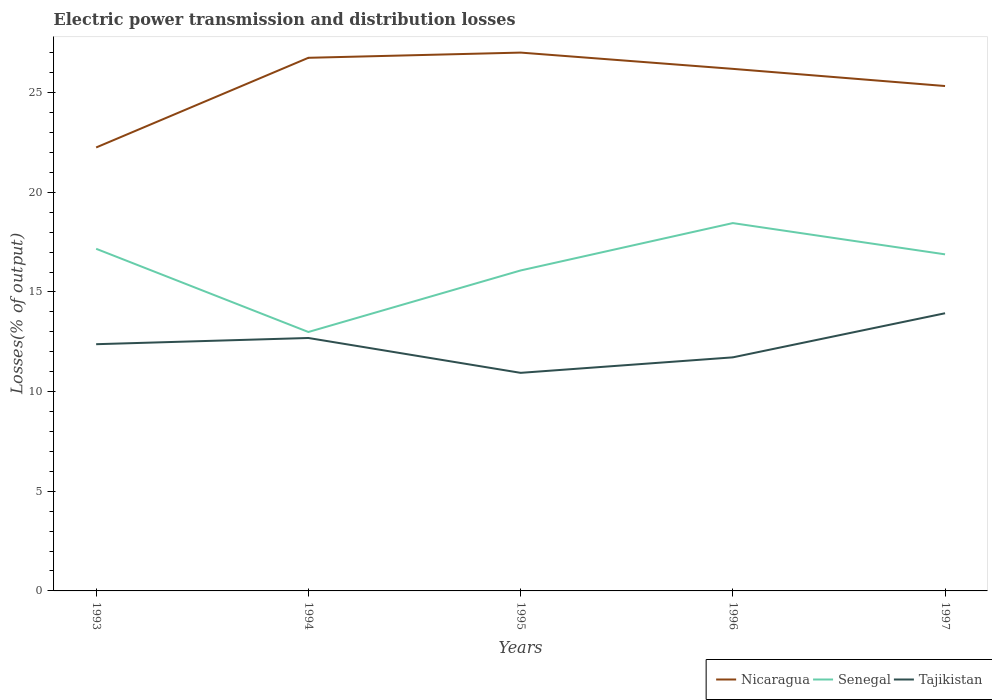Is the number of lines equal to the number of legend labels?
Your answer should be compact. Yes. Across all years, what is the maximum electric power transmission and distribution losses in Tajikistan?
Offer a terse response. 10.94. What is the total electric power transmission and distribution losses in Tajikistan in the graph?
Provide a succinct answer. -0.78. What is the difference between the highest and the second highest electric power transmission and distribution losses in Nicaragua?
Your response must be concise. 4.76. How many years are there in the graph?
Provide a short and direct response. 5. Are the values on the major ticks of Y-axis written in scientific E-notation?
Your answer should be compact. No. Does the graph contain any zero values?
Ensure brevity in your answer.  No. Where does the legend appear in the graph?
Offer a terse response. Bottom right. What is the title of the graph?
Provide a succinct answer. Electric power transmission and distribution losses. Does "Singapore" appear as one of the legend labels in the graph?
Offer a very short reply. No. What is the label or title of the X-axis?
Offer a very short reply. Years. What is the label or title of the Y-axis?
Provide a succinct answer. Losses(% of output). What is the Losses(% of output) of Nicaragua in 1993?
Provide a succinct answer. 22.25. What is the Losses(% of output) of Senegal in 1993?
Provide a succinct answer. 17.16. What is the Losses(% of output) of Tajikistan in 1993?
Your response must be concise. 12.38. What is the Losses(% of output) of Nicaragua in 1994?
Your answer should be very brief. 26.75. What is the Losses(% of output) of Senegal in 1994?
Provide a succinct answer. 12.99. What is the Losses(% of output) in Tajikistan in 1994?
Offer a terse response. 12.69. What is the Losses(% of output) of Nicaragua in 1995?
Ensure brevity in your answer.  27.01. What is the Losses(% of output) in Senegal in 1995?
Make the answer very short. 16.08. What is the Losses(% of output) in Tajikistan in 1995?
Give a very brief answer. 10.94. What is the Losses(% of output) of Nicaragua in 1996?
Your answer should be compact. 26.19. What is the Losses(% of output) in Senegal in 1996?
Ensure brevity in your answer.  18.45. What is the Losses(% of output) of Tajikistan in 1996?
Make the answer very short. 11.72. What is the Losses(% of output) of Nicaragua in 1997?
Ensure brevity in your answer.  25.33. What is the Losses(% of output) in Senegal in 1997?
Provide a succinct answer. 16.89. What is the Losses(% of output) in Tajikistan in 1997?
Keep it short and to the point. 13.93. Across all years, what is the maximum Losses(% of output) of Nicaragua?
Offer a very short reply. 27.01. Across all years, what is the maximum Losses(% of output) of Senegal?
Your response must be concise. 18.45. Across all years, what is the maximum Losses(% of output) in Tajikistan?
Your answer should be compact. 13.93. Across all years, what is the minimum Losses(% of output) in Nicaragua?
Provide a succinct answer. 22.25. Across all years, what is the minimum Losses(% of output) in Senegal?
Keep it short and to the point. 12.99. Across all years, what is the minimum Losses(% of output) in Tajikistan?
Offer a very short reply. 10.94. What is the total Losses(% of output) of Nicaragua in the graph?
Offer a very short reply. 127.52. What is the total Losses(% of output) of Senegal in the graph?
Your response must be concise. 81.57. What is the total Losses(% of output) in Tajikistan in the graph?
Your response must be concise. 61.66. What is the difference between the Losses(% of output) of Nicaragua in 1993 and that in 1994?
Keep it short and to the point. -4.5. What is the difference between the Losses(% of output) in Senegal in 1993 and that in 1994?
Your answer should be compact. 4.17. What is the difference between the Losses(% of output) of Tajikistan in 1993 and that in 1994?
Your response must be concise. -0.31. What is the difference between the Losses(% of output) of Nicaragua in 1993 and that in 1995?
Make the answer very short. -4.76. What is the difference between the Losses(% of output) of Senegal in 1993 and that in 1995?
Your answer should be compact. 1.09. What is the difference between the Losses(% of output) of Tajikistan in 1993 and that in 1995?
Make the answer very short. 1.44. What is the difference between the Losses(% of output) in Nicaragua in 1993 and that in 1996?
Ensure brevity in your answer.  -3.94. What is the difference between the Losses(% of output) of Senegal in 1993 and that in 1996?
Your response must be concise. -1.29. What is the difference between the Losses(% of output) of Tajikistan in 1993 and that in 1996?
Keep it short and to the point. 0.66. What is the difference between the Losses(% of output) of Nicaragua in 1993 and that in 1997?
Your answer should be compact. -3.08. What is the difference between the Losses(% of output) in Senegal in 1993 and that in 1997?
Ensure brevity in your answer.  0.28. What is the difference between the Losses(% of output) in Tajikistan in 1993 and that in 1997?
Offer a terse response. -1.55. What is the difference between the Losses(% of output) of Nicaragua in 1994 and that in 1995?
Your response must be concise. -0.26. What is the difference between the Losses(% of output) of Senegal in 1994 and that in 1995?
Make the answer very short. -3.09. What is the difference between the Losses(% of output) in Tajikistan in 1994 and that in 1995?
Offer a terse response. 1.75. What is the difference between the Losses(% of output) of Nicaragua in 1994 and that in 1996?
Offer a terse response. 0.56. What is the difference between the Losses(% of output) in Senegal in 1994 and that in 1996?
Your answer should be very brief. -5.46. What is the difference between the Losses(% of output) of Tajikistan in 1994 and that in 1996?
Ensure brevity in your answer.  0.97. What is the difference between the Losses(% of output) in Nicaragua in 1994 and that in 1997?
Your response must be concise. 1.42. What is the difference between the Losses(% of output) in Senegal in 1994 and that in 1997?
Your answer should be compact. -3.9. What is the difference between the Losses(% of output) in Tajikistan in 1994 and that in 1997?
Ensure brevity in your answer.  -1.24. What is the difference between the Losses(% of output) of Nicaragua in 1995 and that in 1996?
Your answer should be compact. 0.82. What is the difference between the Losses(% of output) of Senegal in 1995 and that in 1996?
Provide a succinct answer. -2.38. What is the difference between the Losses(% of output) of Tajikistan in 1995 and that in 1996?
Your answer should be compact. -0.78. What is the difference between the Losses(% of output) of Nicaragua in 1995 and that in 1997?
Provide a succinct answer. 1.68. What is the difference between the Losses(% of output) in Senegal in 1995 and that in 1997?
Give a very brief answer. -0.81. What is the difference between the Losses(% of output) of Tajikistan in 1995 and that in 1997?
Provide a succinct answer. -2.99. What is the difference between the Losses(% of output) in Nicaragua in 1996 and that in 1997?
Your answer should be very brief. 0.86. What is the difference between the Losses(% of output) in Senegal in 1996 and that in 1997?
Your answer should be compact. 1.57. What is the difference between the Losses(% of output) of Tajikistan in 1996 and that in 1997?
Ensure brevity in your answer.  -2.21. What is the difference between the Losses(% of output) of Nicaragua in 1993 and the Losses(% of output) of Senegal in 1994?
Offer a very short reply. 9.26. What is the difference between the Losses(% of output) in Nicaragua in 1993 and the Losses(% of output) in Tajikistan in 1994?
Keep it short and to the point. 9.56. What is the difference between the Losses(% of output) in Senegal in 1993 and the Losses(% of output) in Tajikistan in 1994?
Provide a succinct answer. 4.47. What is the difference between the Losses(% of output) in Nicaragua in 1993 and the Losses(% of output) in Senegal in 1995?
Keep it short and to the point. 6.17. What is the difference between the Losses(% of output) in Nicaragua in 1993 and the Losses(% of output) in Tajikistan in 1995?
Keep it short and to the point. 11.31. What is the difference between the Losses(% of output) in Senegal in 1993 and the Losses(% of output) in Tajikistan in 1995?
Your answer should be compact. 6.22. What is the difference between the Losses(% of output) of Nicaragua in 1993 and the Losses(% of output) of Senegal in 1996?
Make the answer very short. 3.79. What is the difference between the Losses(% of output) of Nicaragua in 1993 and the Losses(% of output) of Tajikistan in 1996?
Provide a short and direct response. 10.53. What is the difference between the Losses(% of output) of Senegal in 1993 and the Losses(% of output) of Tajikistan in 1996?
Ensure brevity in your answer.  5.45. What is the difference between the Losses(% of output) in Nicaragua in 1993 and the Losses(% of output) in Senegal in 1997?
Provide a short and direct response. 5.36. What is the difference between the Losses(% of output) in Nicaragua in 1993 and the Losses(% of output) in Tajikistan in 1997?
Make the answer very short. 8.32. What is the difference between the Losses(% of output) in Senegal in 1993 and the Losses(% of output) in Tajikistan in 1997?
Your response must be concise. 3.23. What is the difference between the Losses(% of output) in Nicaragua in 1994 and the Losses(% of output) in Senegal in 1995?
Ensure brevity in your answer.  10.67. What is the difference between the Losses(% of output) in Nicaragua in 1994 and the Losses(% of output) in Tajikistan in 1995?
Keep it short and to the point. 15.81. What is the difference between the Losses(% of output) of Senegal in 1994 and the Losses(% of output) of Tajikistan in 1995?
Offer a very short reply. 2.05. What is the difference between the Losses(% of output) in Nicaragua in 1994 and the Losses(% of output) in Senegal in 1996?
Provide a succinct answer. 8.29. What is the difference between the Losses(% of output) in Nicaragua in 1994 and the Losses(% of output) in Tajikistan in 1996?
Ensure brevity in your answer.  15.03. What is the difference between the Losses(% of output) in Senegal in 1994 and the Losses(% of output) in Tajikistan in 1996?
Give a very brief answer. 1.27. What is the difference between the Losses(% of output) in Nicaragua in 1994 and the Losses(% of output) in Senegal in 1997?
Offer a terse response. 9.86. What is the difference between the Losses(% of output) of Nicaragua in 1994 and the Losses(% of output) of Tajikistan in 1997?
Your answer should be very brief. 12.82. What is the difference between the Losses(% of output) of Senegal in 1994 and the Losses(% of output) of Tajikistan in 1997?
Your answer should be very brief. -0.94. What is the difference between the Losses(% of output) in Nicaragua in 1995 and the Losses(% of output) in Senegal in 1996?
Offer a very short reply. 8.55. What is the difference between the Losses(% of output) in Nicaragua in 1995 and the Losses(% of output) in Tajikistan in 1996?
Offer a terse response. 15.29. What is the difference between the Losses(% of output) of Senegal in 1995 and the Losses(% of output) of Tajikistan in 1996?
Provide a succinct answer. 4.36. What is the difference between the Losses(% of output) of Nicaragua in 1995 and the Losses(% of output) of Senegal in 1997?
Provide a succinct answer. 10.12. What is the difference between the Losses(% of output) in Nicaragua in 1995 and the Losses(% of output) in Tajikistan in 1997?
Give a very brief answer. 13.08. What is the difference between the Losses(% of output) of Senegal in 1995 and the Losses(% of output) of Tajikistan in 1997?
Keep it short and to the point. 2.15. What is the difference between the Losses(% of output) of Nicaragua in 1996 and the Losses(% of output) of Senegal in 1997?
Offer a terse response. 9.31. What is the difference between the Losses(% of output) in Nicaragua in 1996 and the Losses(% of output) in Tajikistan in 1997?
Ensure brevity in your answer.  12.26. What is the difference between the Losses(% of output) of Senegal in 1996 and the Losses(% of output) of Tajikistan in 1997?
Make the answer very short. 4.52. What is the average Losses(% of output) of Nicaragua per year?
Keep it short and to the point. 25.5. What is the average Losses(% of output) in Senegal per year?
Keep it short and to the point. 16.31. What is the average Losses(% of output) of Tajikistan per year?
Offer a terse response. 12.33. In the year 1993, what is the difference between the Losses(% of output) of Nicaragua and Losses(% of output) of Senegal?
Your answer should be compact. 5.08. In the year 1993, what is the difference between the Losses(% of output) in Nicaragua and Losses(% of output) in Tajikistan?
Ensure brevity in your answer.  9.87. In the year 1993, what is the difference between the Losses(% of output) in Senegal and Losses(% of output) in Tajikistan?
Keep it short and to the point. 4.79. In the year 1994, what is the difference between the Losses(% of output) in Nicaragua and Losses(% of output) in Senegal?
Ensure brevity in your answer.  13.76. In the year 1994, what is the difference between the Losses(% of output) in Nicaragua and Losses(% of output) in Tajikistan?
Make the answer very short. 14.06. In the year 1994, what is the difference between the Losses(% of output) in Senegal and Losses(% of output) in Tajikistan?
Your response must be concise. 0.3. In the year 1995, what is the difference between the Losses(% of output) in Nicaragua and Losses(% of output) in Senegal?
Provide a succinct answer. 10.93. In the year 1995, what is the difference between the Losses(% of output) in Nicaragua and Losses(% of output) in Tajikistan?
Give a very brief answer. 16.07. In the year 1995, what is the difference between the Losses(% of output) in Senegal and Losses(% of output) in Tajikistan?
Provide a short and direct response. 5.14. In the year 1996, what is the difference between the Losses(% of output) in Nicaragua and Losses(% of output) in Senegal?
Ensure brevity in your answer.  7.74. In the year 1996, what is the difference between the Losses(% of output) of Nicaragua and Losses(% of output) of Tajikistan?
Offer a terse response. 14.47. In the year 1996, what is the difference between the Losses(% of output) in Senegal and Losses(% of output) in Tajikistan?
Provide a succinct answer. 6.74. In the year 1997, what is the difference between the Losses(% of output) in Nicaragua and Losses(% of output) in Senegal?
Your answer should be very brief. 8.44. In the year 1997, what is the difference between the Losses(% of output) in Nicaragua and Losses(% of output) in Tajikistan?
Keep it short and to the point. 11.4. In the year 1997, what is the difference between the Losses(% of output) in Senegal and Losses(% of output) in Tajikistan?
Provide a succinct answer. 2.96. What is the ratio of the Losses(% of output) of Nicaragua in 1993 to that in 1994?
Ensure brevity in your answer.  0.83. What is the ratio of the Losses(% of output) of Senegal in 1993 to that in 1994?
Your answer should be compact. 1.32. What is the ratio of the Losses(% of output) of Tajikistan in 1993 to that in 1994?
Your answer should be compact. 0.98. What is the ratio of the Losses(% of output) in Nicaragua in 1993 to that in 1995?
Your answer should be very brief. 0.82. What is the ratio of the Losses(% of output) in Senegal in 1993 to that in 1995?
Your answer should be very brief. 1.07. What is the ratio of the Losses(% of output) in Tajikistan in 1993 to that in 1995?
Give a very brief answer. 1.13. What is the ratio of the Losses(% of output) of Nicaragua in 1993 to that in 1996?
Offer a very short reply. 0.85. What is the ratio of the Losses(% of output) of Senegal in 1993 to that in 1996?
Offer a very short reply. 0.93. What is the ratio of the Losses(% of output) of Tajikistan in 1993 to that in 1996?
Provide a short and direct response. 1.06. What is the ratio of the Losses(% of output) in Nicaragua in 1993 to that in 1997?
Your response must be concise. 0.88. What is the ratio of the Losses(% of output) in Senegal in 1993 to that in 1997?
Provide a short and direct response. 1.02. What is the ratio of the Losses(% of output) in Tajikistan in 1993 to that in 1997?
Ensure brevity in your answer.  0.89. What is the ratio of the Losses(% of output) of Nicaragua in 1994 to that in 1995?
Keep it short and to the point. 0.99. What is the ratio of the Losses(% of output) in Senegal in 1994 to that in 1995?
Your response must be concise. 0.81. What is the ratio of the Losses(% of output) in Tajikistan in 1994 to that in 1995?
Offer a very short reply. 1.16. What is the ratio of the Losses(% of output) of Nicaragua in 1994 to that in 1996?
Give a very brief answer. 1.02. What is the ratio of the Losses(% of output) in Senegal in 1994 to that in 1996?
Offer a terse response. 0.7. What is the ratio of the Losses(% of output) of Tajikistan in 1994 to that in 1996?
Your answer should be compact. 1.08. What is the ratio of the Losses(% of output) in Nicaragua in 1994 to that in 1997?
Your answer should be very brief. 1.06. What is the ratio of the Losses(% of output) in Senegal in 1994 to that in 1997?
Make the answer very short. 0.77. What is the ratio of the Losses(% of output) of Tajikistan in 1994 to that in 1997?
Offer a very short reply. 0.91. What is the ratio of the Losses(% of output) of Nicaragua in 1995 to that in 1996?
Your response must be concise. 1.03. What is the ratio of the Losses(% of output) in Senegal in 1995 to that in 1996?
Provide a succinct answer. 0.87. What is the ratio of the Losses(% of output) in Tajikistan in 1995 to that in 1996?
Make the answer very short. 0.93. What is the ratio of the Losses(% of output) of Nicaragua in 1995 to that in 1997?
Make the answer very short. 1.07. What is the ratio of the Losses(% of output) of Senegal in 1995 to that in 1997?
Keep it short and to the point. 0.95. What is the ratio of the Losses(% of output) in Tajikistan in 1995 to that in 1997?
Ensure brevity in your answer.  0.79. What is the ratio of the Losses(% of output) of Nicaragua in 1996 to that in 1997?
Keep it short and to the point. 1.03. What is the ratio of the Losses(% of output) of Senegal in 1996 to that in 1997?
Your answer should be compact. 1.09. What is the ratio of the Losses(% of output) of Tajikistan in 1996 to that in 1997?
Offer a very short reply. 0.84. What is the difference between the highest and the second highest Losses(% of output) in Nicaragua?
Keep it short and to the point. 0.26. What is the difference between the highest and the second highest Losses(% of output) in Senegal?
Your response must be concise. 1.29. What is the difference between the highest and the second highest Losses(% of output) in Tajikistan?
Offer a very short reply. 1.24. What is the difference between the highest and the lowest Losses(% of output) of Nicaragua?
Give a very brief answer. 4.76. What is the difference between the highest and the lowest Losses(% of output) of Senegal?
Keep it short and to the point. 5.46. What is the difference between the highest and the lowest Losses(% of output) of Tajikistan?
Keep it short and to the point. 2.99. 